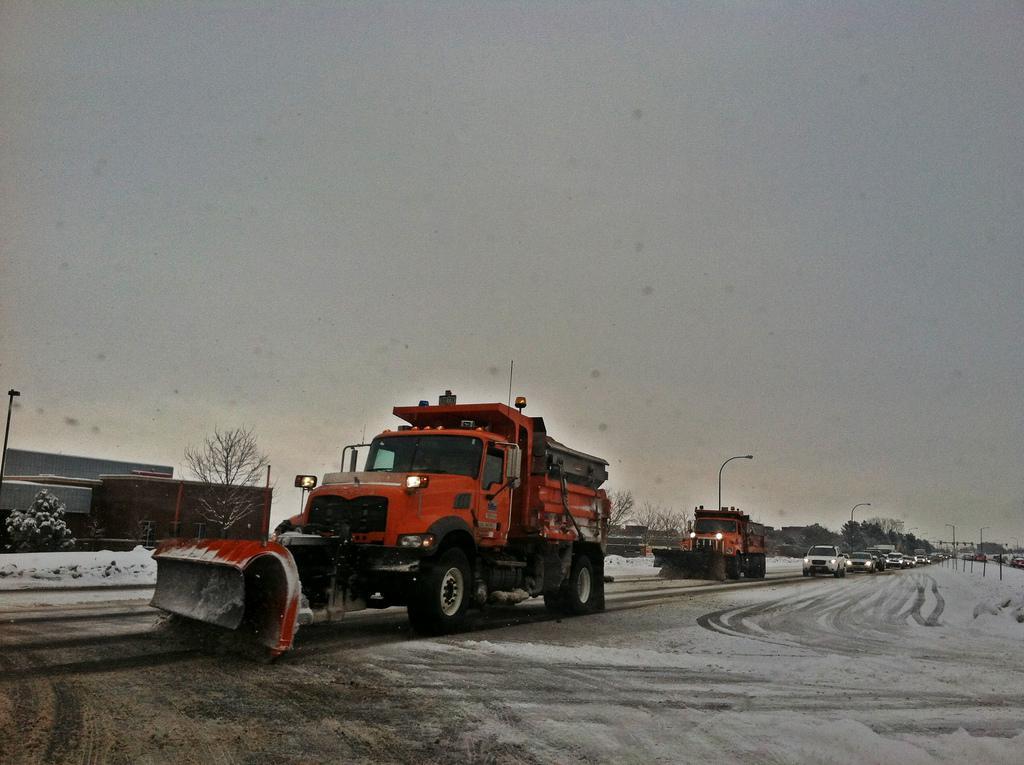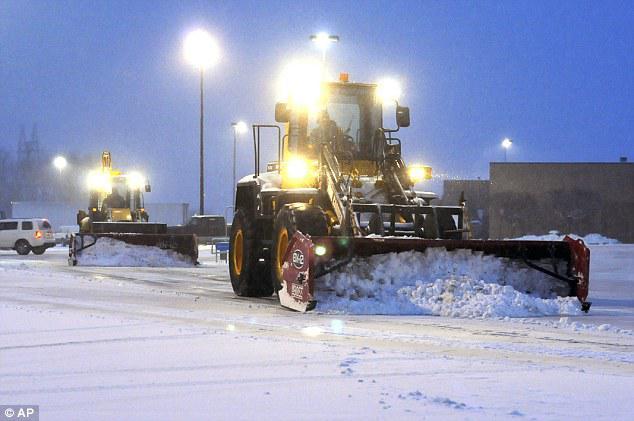The first image is the image on the left, the second image is the image on the right. Assess this claim about the two images: "There is exactly one snow plow in the right image.". Correct or not? Answer yes or no. No. The first image is the image on the left, the second image is the image on the right. Analyze the images presented: Is the assertion "There is exactly one truck, with a yellow plow attached." valid? Answer yes or no. No. 